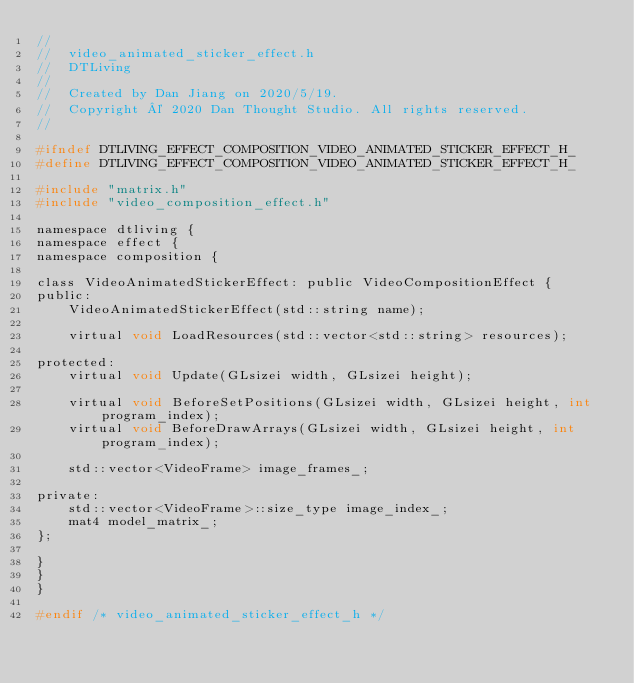Convert code to text. <code><loc_0><loc_0><loc_500><loc_500><_C_>//
//  video_animated_sticker_effect.h
//  DTLiving
//
//  Created by Dan Jiang on 2020/5/19.
//  Copyright © 2020 Dan Thought Studio. All rights reserved.
//

#ifndef DTLIVING_EFFECT_COMPOSITION_VIDEO_ANIMATED_STICKER_EFFECT_H_
#define DTLIVING_EFFECT_COMPOSITION_VIDEO_ANIMATED_STICKER_EFFECT_H_

#include "matrix.h"
#include "video_composition_effect.h"

namespace dtliving {
namespace effect {
namespace composition {

class VideoAnimatedStickerEffect: public VideoCompositionEffect {
public:
    VideoAnimatedStickerEffect(std::string name);
    
    virtual void LoadResources(std::vector<std::string> resources);

protected:
    virtual void Update(GLsizei width, GLsizei height);
    
    virtual void BeforeSetPositions(GLsizei width, GLsizei height, int program_index);
    virtual void BeforeDrawArrays(GLsizei width, GLsizei height, int program_index);

    std::vector<VideoFrame> image_frames_;
    
private:
    std::vector<VideoFrame>::size_type image_index_;
    mat4 model_matrix_;
};

}
}
}

#endif /* video_animated_sticker_effect_h */
</code> 